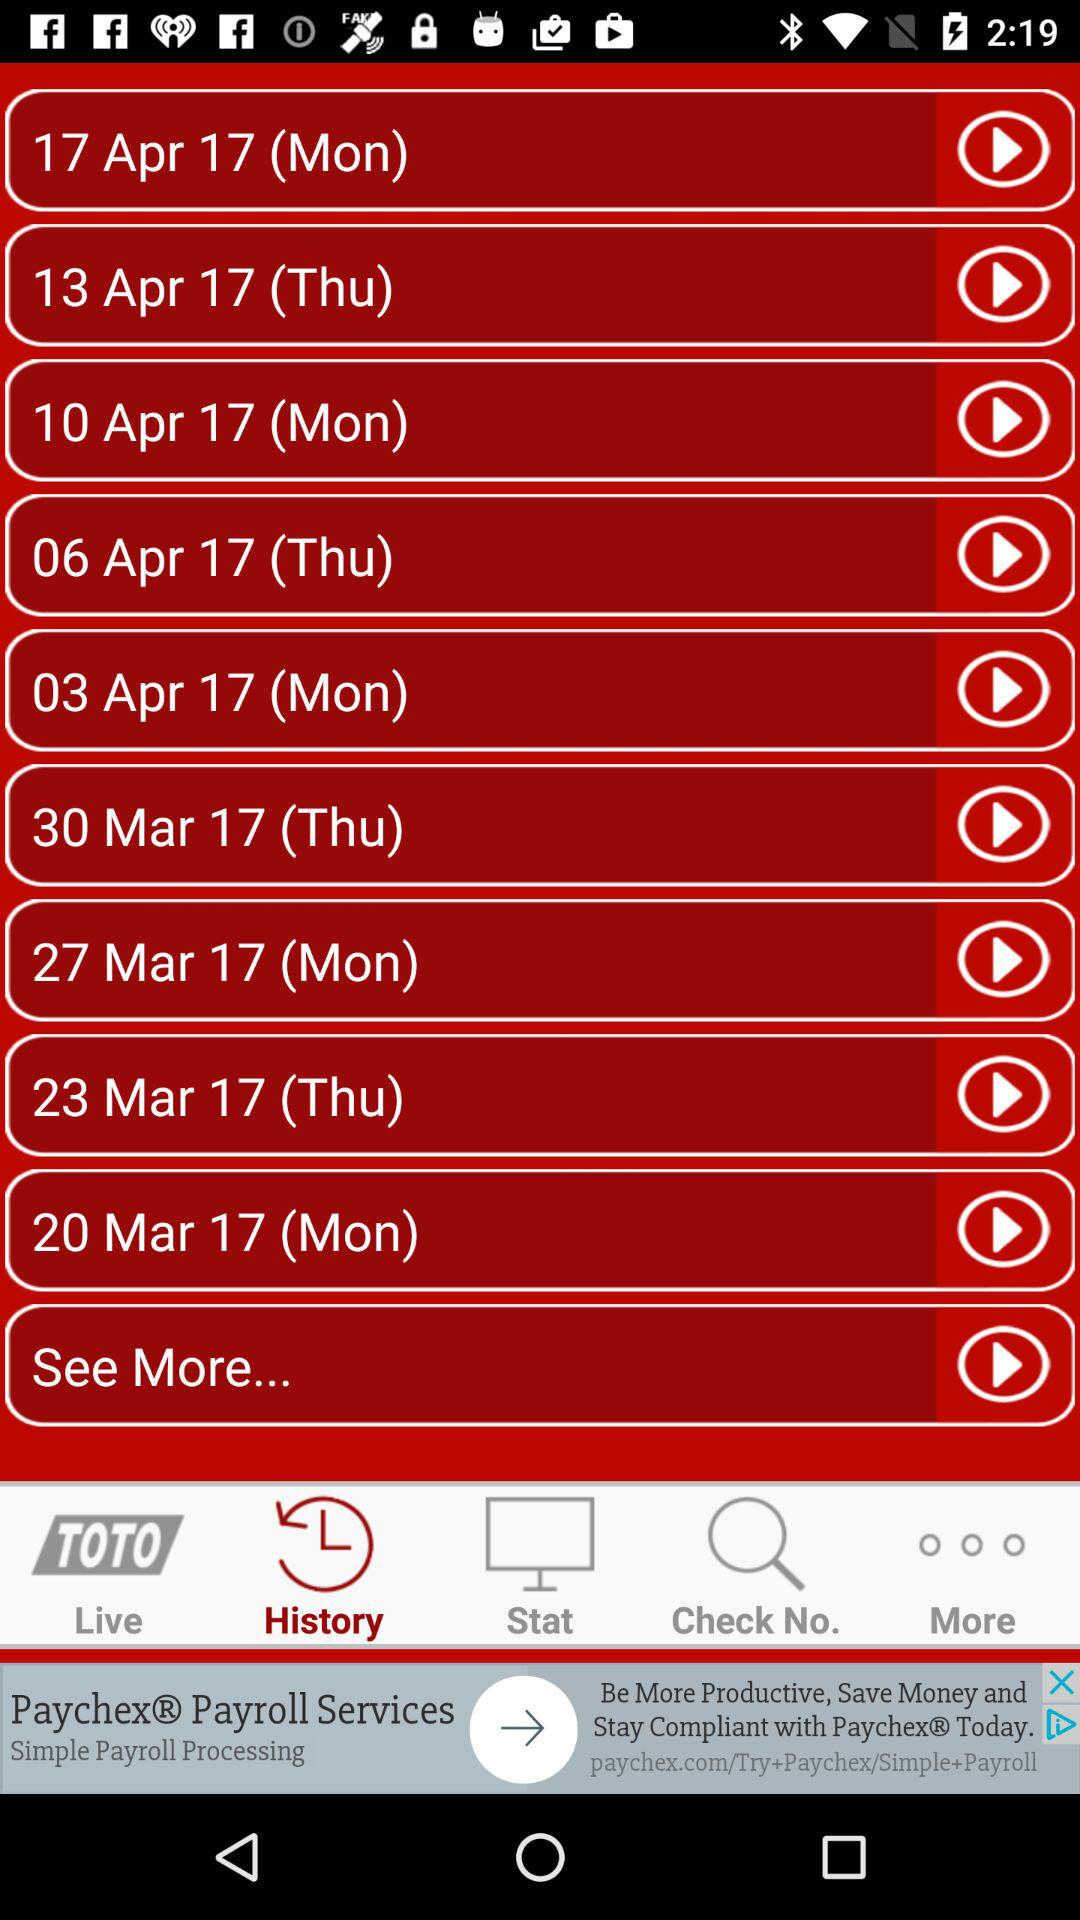What's the day on 06th of April, 2017? The day is Thursday. 